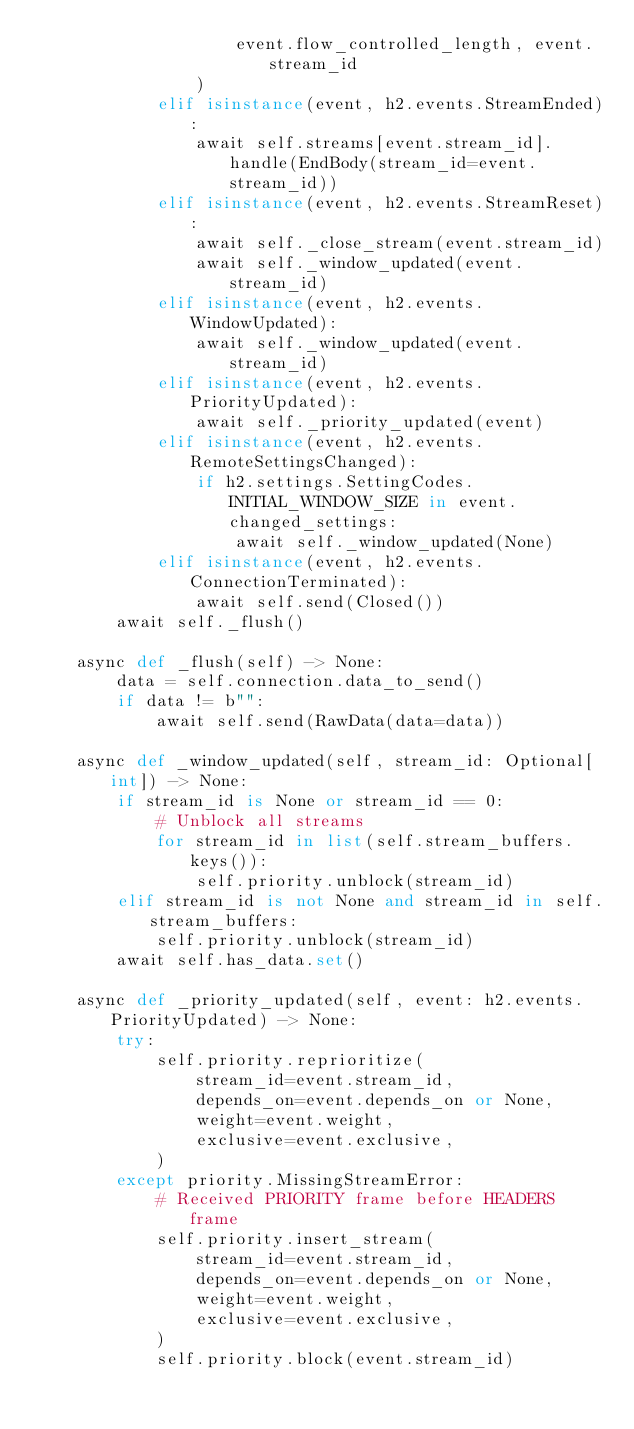Convert code to text. <code><loc_0><loc_0><loc_500><loc_500><_Python_>                    event.flow_controlled_length, event.stream_id
                )
            elif isinstance(event, h2.events.StreamEnded):
                await self.streams[event.stream_id].handle(EndBody(stream_id=event.stream_id))
            elif isinstance(event, h2.events.StreamReset):
                await self._close_stream(event.stream_id)
                await self._window_updated(event.stream_id)
            elif isinstance(event, h2.events.WindowUpdated):
                await self._window_updated(event.stream_id)
            elif isinstance(event, h2.events.PriorityUpdated):
                await self._priority_updated(event)
            elif isinstance(event, h2.events.RemoteSettingsChanged):
                if h2.settings.SettingCodes.INITIAL_WINDOW_SIZE in event.changed_settings:
                    await self._window_updated(None)
            elif isinstance(event, h2.events.ConnectionTerminated):
                await self.send(Closed())
        await self._flush()

    async def _flush(self) -> None:
        data = self.connection.data_to_send()
        if data != b"":
            await self.send(RawData(data=data))

    async def _window_updated(self, stream_id: Optional[int]) -> None:
        if stream_id is None or stream_id == 0:
            # Unblock all streams
            for stream_id in list(self.stream_buffers.keys()):
                self.priority.unblock(stream_id)
        elif stream_id is not None and stream_id in self.stream_buffers:
            self.priority.unblock(stream_id)
        await self.has_data.set()

    async def _priority_updated(self, event: h2.events.PriorityUpdated) -> None:
        try:
            self.priority.reprioritize(
                stream_id=event.stream_id,
                depends_on=event.depends_on or None,
                weight=event.weight,
                exclusive=event.exclusive,
            )
        except priority.MissingStreamError:
            # Received PRIORITY frame before HEADERS frame
            self.priority.insert_stream(
                stream_id=event.stream_id,
                depends_on=event.depends_on or None,
                weight=event.weight,
                exclusive=event.exclusive,
            )
            self.priority.block(event.stream_id)</code> 